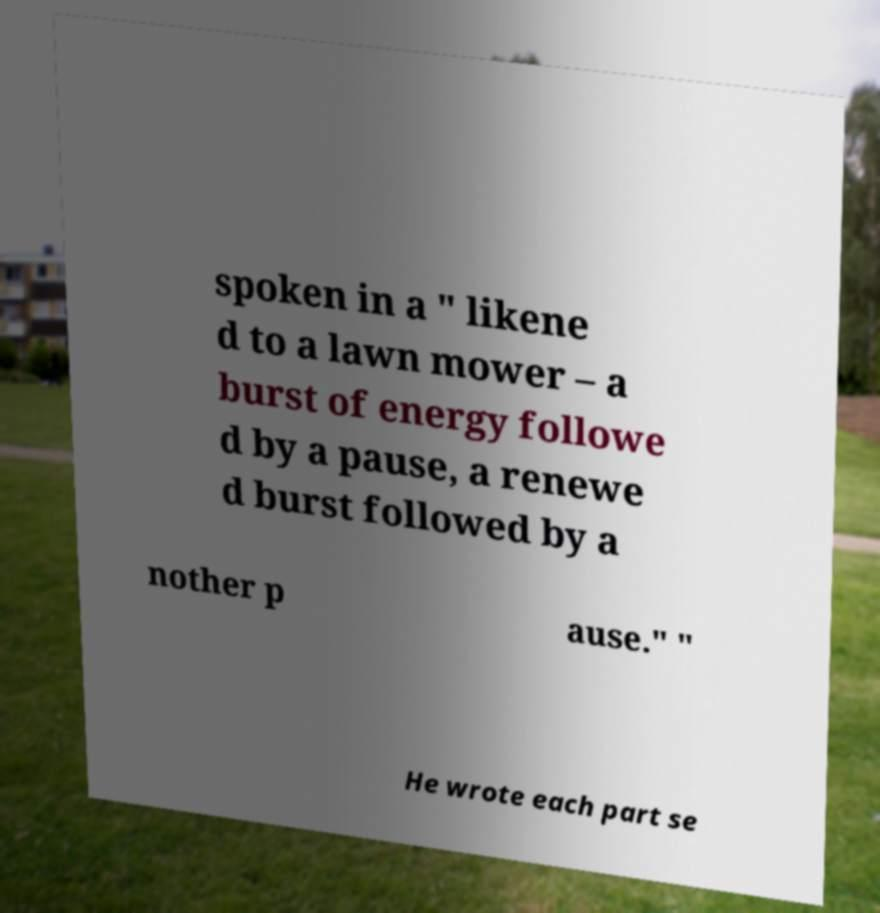What messages or text are displayed in this image? I need them in a readable, typed format. spoken in a " likene d to a lawn mower – a burst of energy followe d by a pause, a renewe d burst followed by a nother p ause." " He wrote each part se 